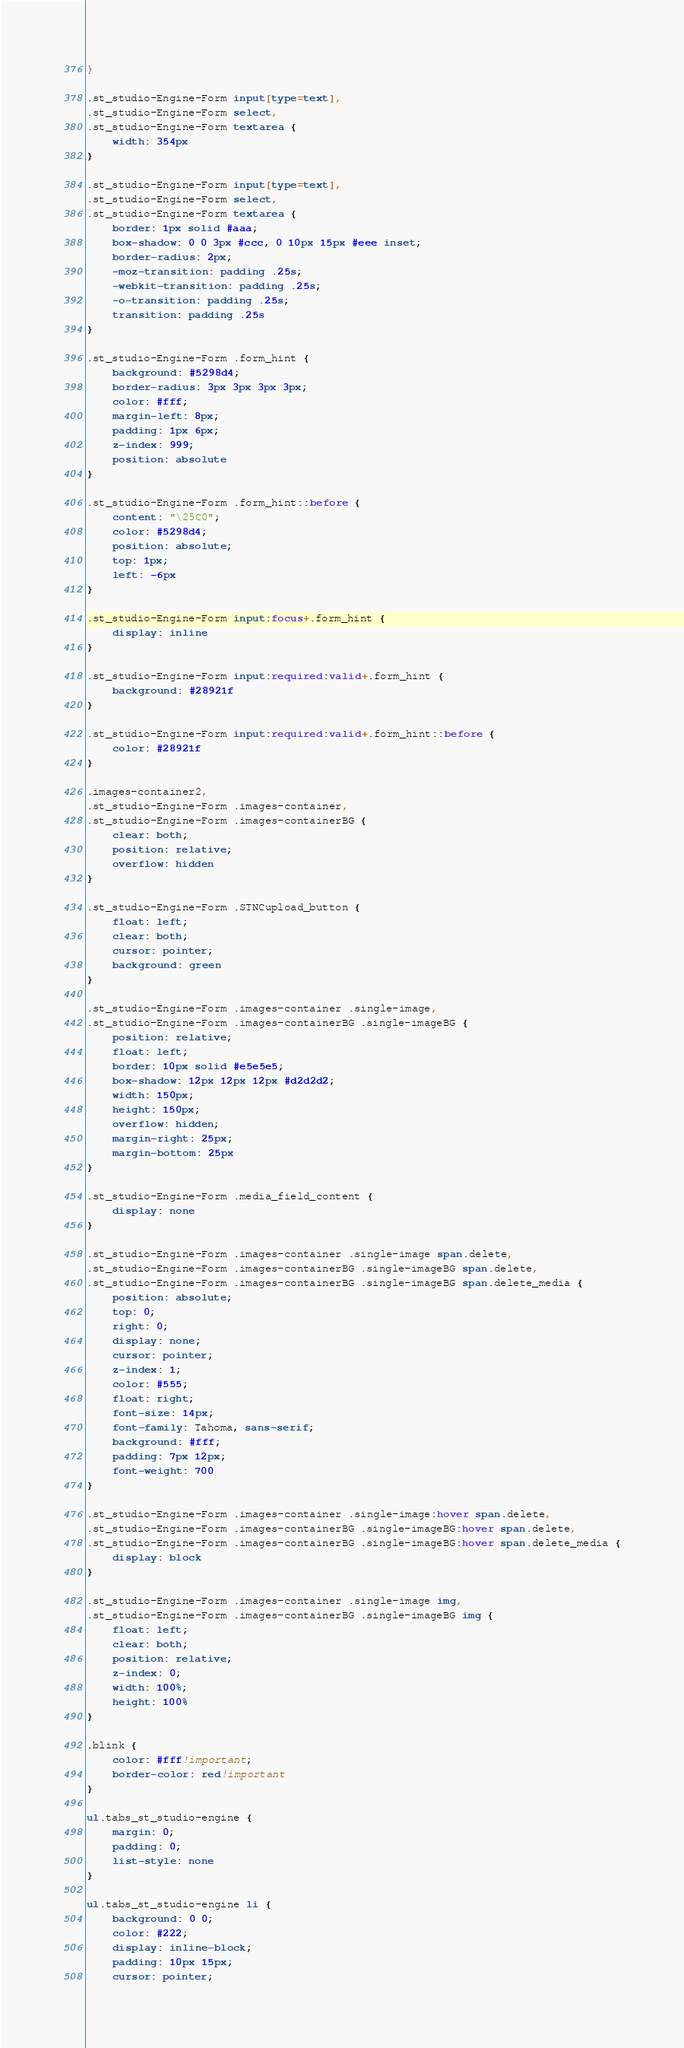Convert code to text. <code><loc_0><loc_0><loc_500><loc_500><_CSS_>}

.st_studio-Engine-Form input[type=text],
.st_studio-Engine-Form select,
.st_studio-Engine-Form textarea {
    width: 354px
}

.st_studio-Engine-Form input[type=text],
.st_studio-Engine-Form select,
.st_studio-Engine-Form textarea {
    border: 1px solid #aaa;
    box-shadow: 0 0 3px #ccc, 0 10px 15px #eee inset;
    border-radius: 2px;
    -moz-transition: padding .25s;
    -webkit-transition: padding .25s;
    -o-transition: padding .25s;
    transition: padding .25s
}

.st_studio-Engine-Form .form_hint {
    background: #5298d4;
    border-radius: 3px 3px 3px 3px;
    color: #fff;
    margin-left: 8px;
    padding: 1px 6px;
    z-index: 999;
    position: absolute
}

.st_studio-Engine-Form .form_hint::before {
    content: "\25C0";
    color: #5298d4;
    position: absolute;
    top: 1px;
    left: -6px
}

.st_studio-Engine-Form input:focus+.form_hint {
    display: inline
}

.st_studio-Engine-Form input:required:valid+.form_hint {
    background: #28921f
}

.st_studio-Engine-Form input:required:valid+.form_hint::before {
    color: #28921f
}

.images-container2,
.st_studio-Engine-Form .images-container,
.st_studio-Engine-Form .images-containerBG {
    clear: both;
    position: relative;
    overflow: hidden
}

.st_studio-Engine-Form .STNCupload_button {
    float: left;
    clear: both;
    cursor: pointer;
    background: green
}

.st_studio-Engine-Form .images-container .single-image,
.st_studio-Engine-Form .images-containerBG .single-imageBG {
    position: relative;
    float: left;
    border: 10px solid #e5e5e5;
    box-shadow: 12px 12px 12px #d2d2d2;
    width: 150px;
    height: 150px;
    overflow: hidden;
    margin-right: 25px;
    margin-bottom: 25px
}

.st_studio-Engine-Form .media_field_content {
    display: none
}

.st_studio-Engine-Form .images-container .single-image span.delete,
.st_studio-Engine-Form .images-containerBG .single-imageBG span.delete,
.st_studio-Engine-Form .images-containerBG .single-imageBG span.delete_media {
    position: absolute;
    top: 0;
    right: 0;
    display: none;
    cursor: pointer;
    z-index: 1;
    color: #555;
    float: right;
    font-size: 14px;
    font-family: Tahoma, sans-serif;
    background: #fff;
    padding: 7px 12px;
    font-weight: 700
}

.st_studio-Engine-Form .images-container .single-image:hover span.delete,
.st_studio-Engine-Form .images-containerBG .single-imageBG:hover span.delete,
.st_studio-Engine-Form .images-containerBG .single-imageBG:hover span.delete_media {
    display: block
}

.st_studio-Engine-Form .images-container .single-image img,
.st_studio-Engine-Form .images-containerBG .single-imageBG img {
    float: left;
    clear: both;
    position: relative;
    z-index: 0;
    width: 100%;
    height: 100%
}

.blink {
    color: #fff!important;
    border-color: red!important
}

ul.tabs_st_studio-engine {
    margin: 0;
    padding: 0;
    list-style: none
}

ul.tabs_st_studio-engine li {
    background: 0 0;
    color: #222;
    display: inline-block;
    padding: 10px 15px;
    cursor: pointer;</code> 